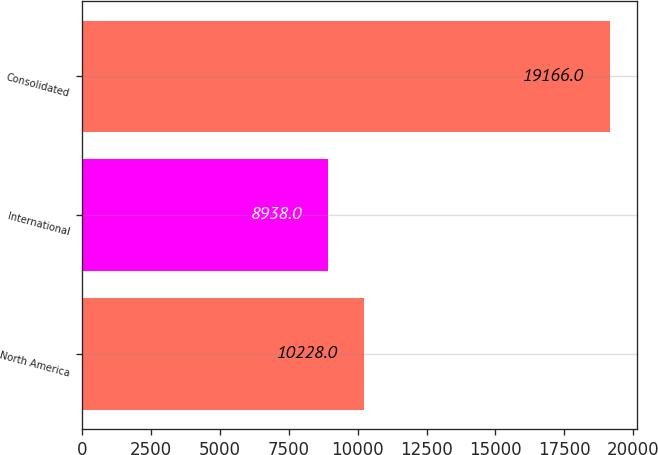Convert chart to OTSL. <chart><loc_0><loc_0><loc_500><loc_500><bar_chart><fcel>North America<fcel>International<fcel>Consolidated<nl><fcel>10228<fcel>8938<fcel>19166<nl></chart> 